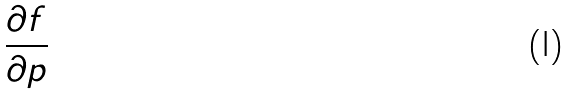<formula> <loc_0><loc_0><loc_500><loc_500>\frac { \partial f } { \partial p }</formula> 